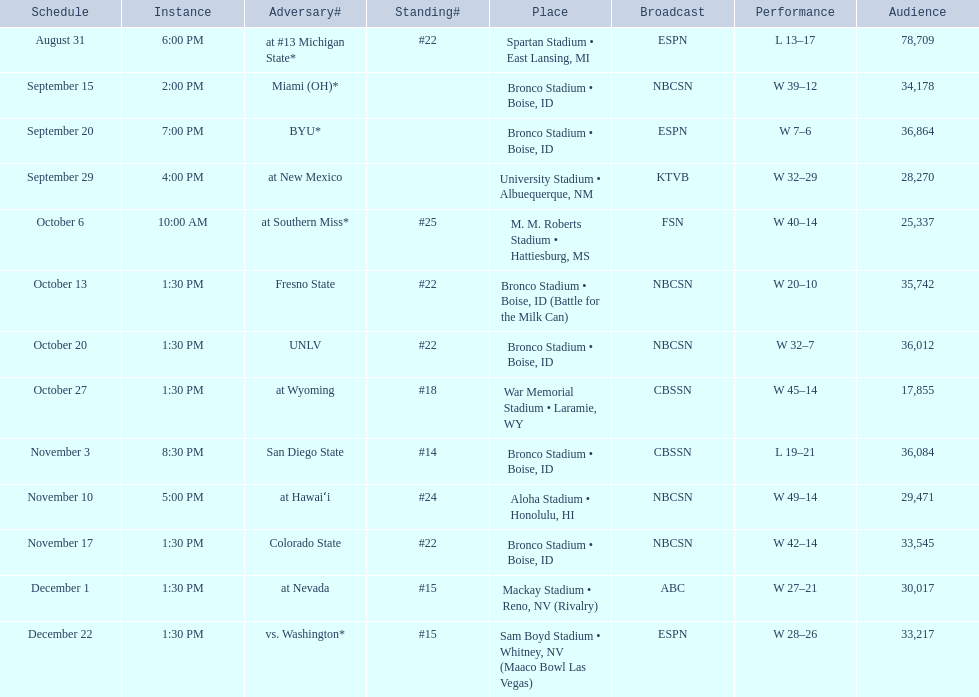Who were all the opponents for boise state? At #13 michigan state*, miami (oh)*, byu*, at new mexico, at southern miss*, fresno state, unlv, at wyoming, san diego state, at hawaiʻi, colorado state, at nevada, vs. washington*. Which opponents were ranked? At #13 michigan state*, #22, at southern miss*, #25, fresno state, #22, unlv, #22, at wyoming, #18, san diego state, #14. Which opponent had the highest rank? San Diego State. 